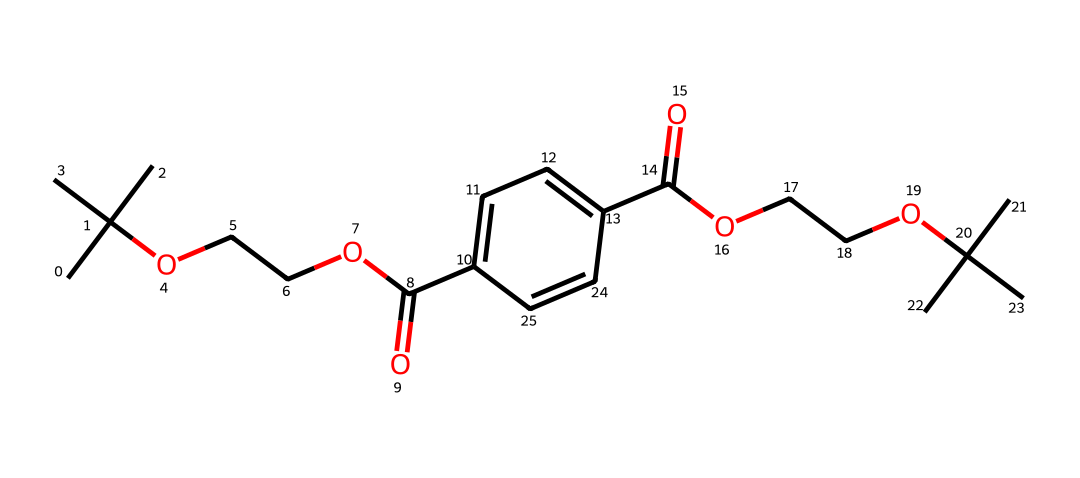How many carbon atoms are present in this chemical? By examining the SMILES representation, we count the number of "C" symbols. In the given structure, there are 15 "C" symbols, indicating that there are 15 carbon atoms.
Answer: 15 What functional groups are present in this compound? Reviewing the chemical structure, we identify that there are ester (-COO-), alcohol (-OH), and carboxylic acid (-COOH) functional groups based on their respective atomic arrangements.
Answer: ester, alcohol, carboxylic acid Is this compound likely to be hydrophobic or hydrophilic? The presence of polar functional groups, such as the carboxylic acid and alcohol, suggests that the compound can interact with water. This balance of hydrophobic (from the hydrocarbon portion) and hydrophilic (from the functional groups) indicates it is likely amphiphilic.
Answer: amphiphilic What is the maximum degree of unsaturation in this structure? The degree of unsaturation can be determined by the formula: (C - H/2 + N/2 + 1). Here, with 15 carbon atoms and 28 hydrogen atoms, this results in a degree of unsaturation of 1, suggesting one double bond or one ring presence in the structure.
Answer: 1 Which part of the chemical contributes to its ability to wick sweat? The ether and alcohol groups enhance moisture absorption and transport, allowing for effective sweat-wicking properties in the fabric. Hence, the presence of these polar groups is crucial for such functionality.
Answer: ether, alcohol What type of reaction would you associate with the formation of esters in this compound? The formation of esters involves a condensation reaction, specifically through the reaction of a carboxylic acid with an alcohol, where water is released (dehydration synthesis). This type of reaction is fundamental in creating the ester linkages found in the structure.
Answer: condensation reaction 